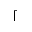Convert formula to latex. <formula><loc_0><loc_0><loc_500><loc_500>\lceil</formula> 